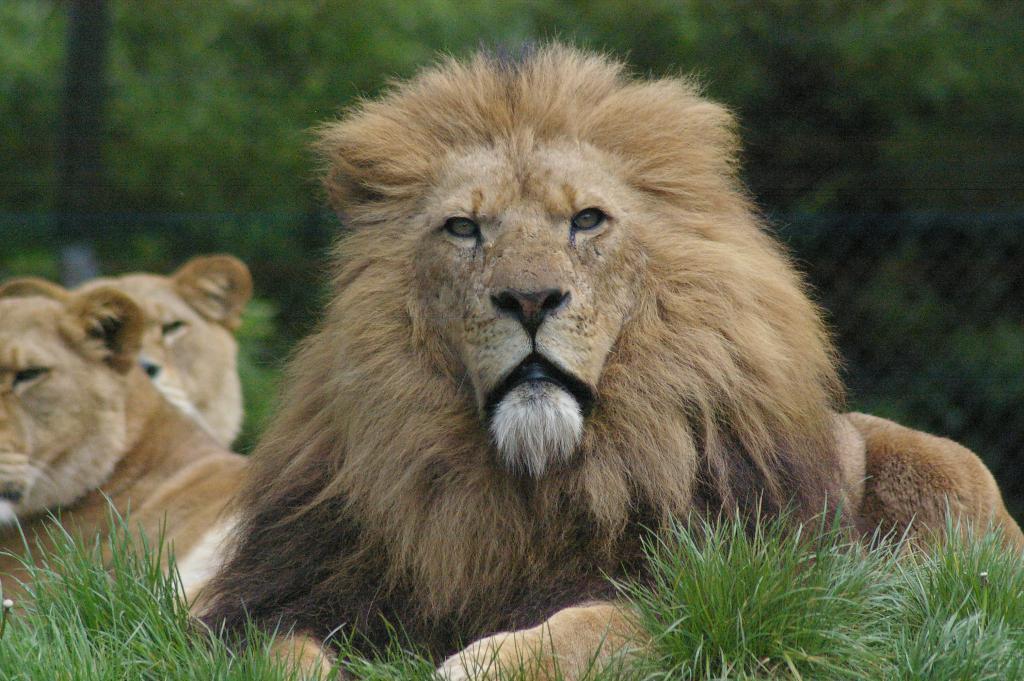Can you describe this image briefly? This image consists of a lion and lioness sitting on the ground. At the bottom, there is green grass. In the background, there are trees. 